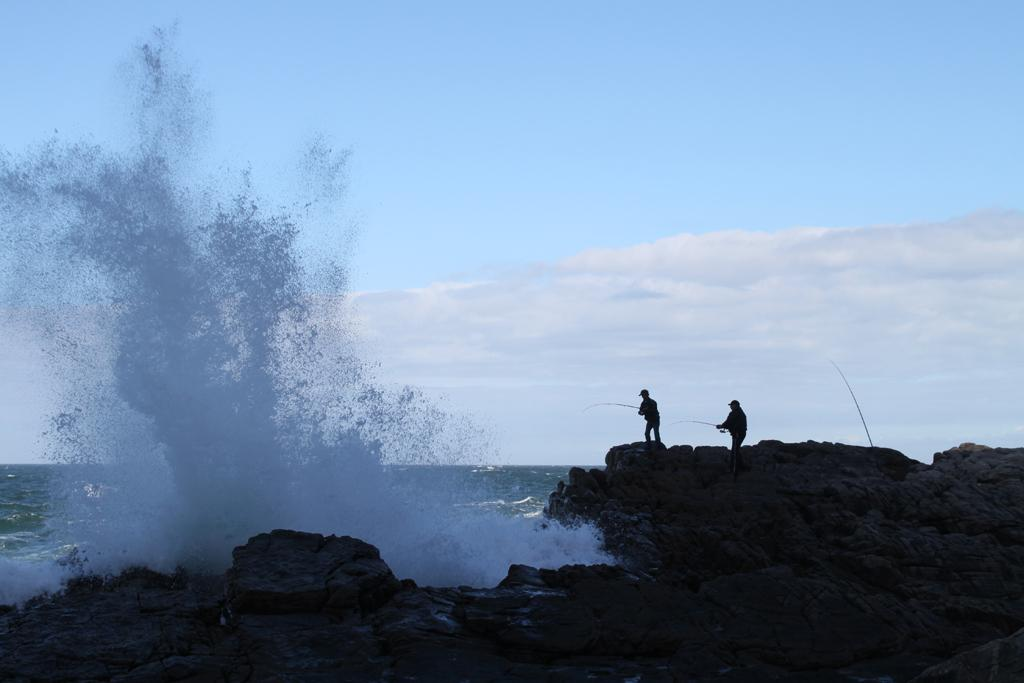How many people are in the image? There are two persons in the image. Where are the persons standing? The persons are standing on a mountain. What is the mountain's location in relation to the ocean? The mountain is in front of the ocean. What is visible at the top of the image? The sky is visible at the top of the image. What can be inferred about the location of the image? The image is likely taken near the ocean, given the presence of the ocean in the background. What type of payment is being made by the persons in the image? There is no indication of any payment being made in the image; the persons are simply standing on a mountain. 